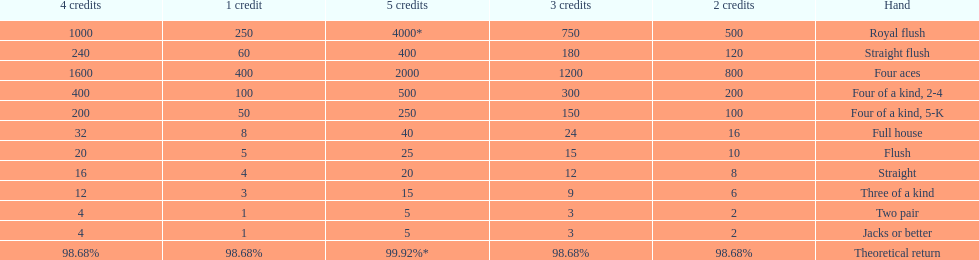The number of flush wins at one credit to equal one flush win at 5 credits. 5. 